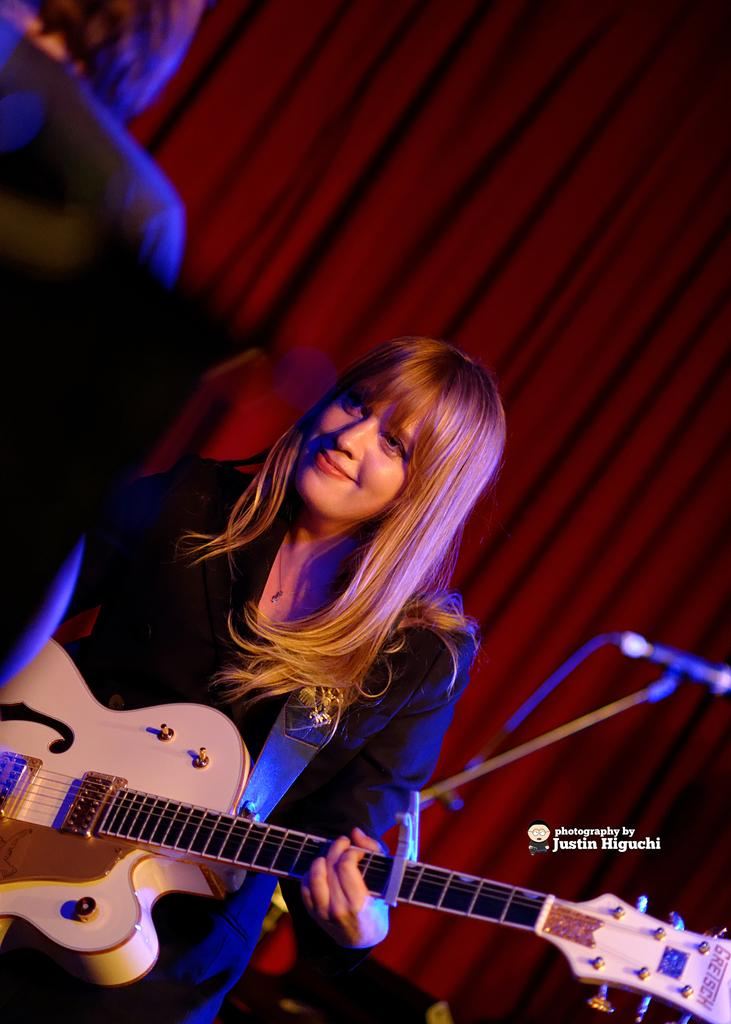What is the woman in the image wearing? The woman is wearing a black dress. What is the woman doing in the image? The woman is standing and holding a guitar in her hand. Can you describe the background of the image? There is a person, a red curtain, and a microphone in the background of the image. What type of animals can be seen in the background of the image? There are no animals visible in the image; it features a woman holding a guitar and a background with a person, a red curtain, and a microphone. 